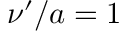<formula> <loc_0><loc_0><loc_500><loc_500>\nu ^ { \prime } / a = 1</formula> 